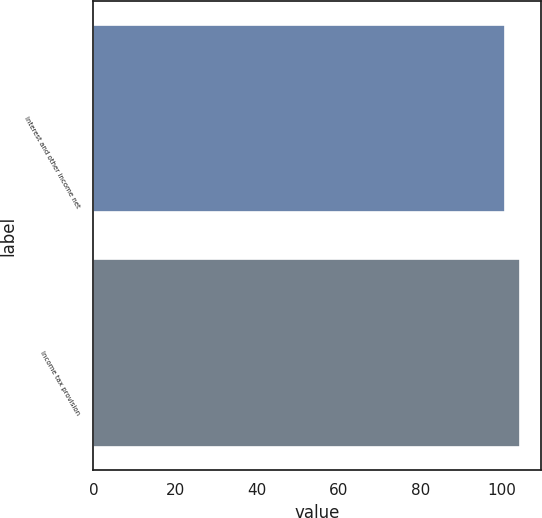Convert chart. <chart><loc_0><loc_0><loc_500><loc_500><bar_chart><fcel>Interest and other income net<fcel>Income tax provision<nl><fcel>100.7<fcel>104.4<nl></chart> 